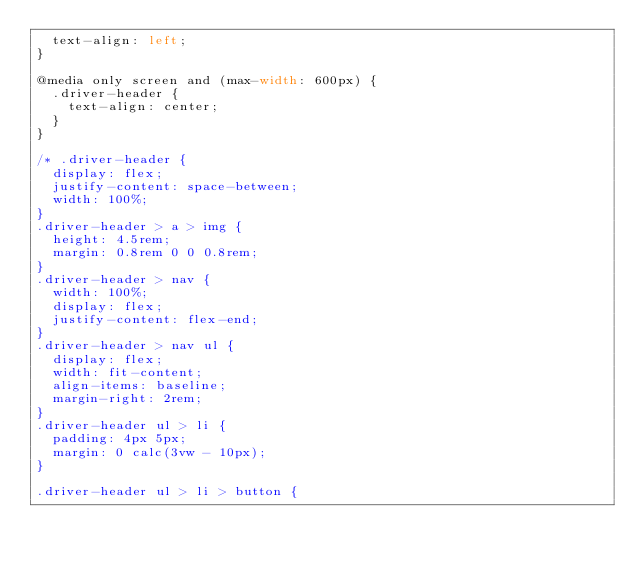Convert code to text. <code><loc_0><loc_0><loc_500><loc_500><_CSS_>  text-align: left;
}

@media only screen and (max-width: 600px) {
  .driver-header {
    text-align: center;
  }
}

/* .driver-header {
  display: flex;
  justify-content: space-between;
  width: 100%;
}
.driver-header > a > img {
  height: 4.5rem;
  margin: 0.8rem 0 0 0.8rem;
}
.driver-header > nav {
  width: 100%;
  display: flex;
  justify-content: flex-end;
}
.driver-header > nav ul {
  display: flex;
  width: fit-content;
  align-items: baseline;
  margin-right: 2rem;
}
.driver-header ul > li {
  padding: 4px 5px;
  margin: 0 calc(3vw - 10px);
}

.driver-header ul > li > button {</code> 